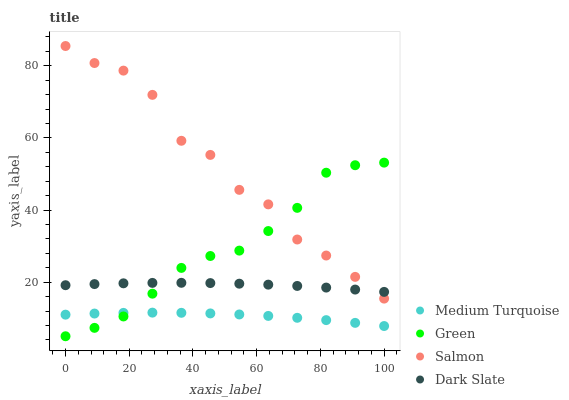Does Medium Turquoise have the minimum area under the curve?
Answer yes or no. Yes. Does Salmon have the maximum area under the curve?
Answer yes or no. Yes. Does Green have the minimum area under the curve?
Answer yes or no. No. Does Green have the maximum area under the curve?
Answer yes or no. No. Is Dark Slate the smoothest?
Answer yes or no. Yes. Is Salmon the roughest?
Answer yes or no. Yes. Is Green the smoothest?
Answer yes or no. No. Is Green the roughest?
Answer yes or no. No. Does Green have the lowest value?
Answer yes or no. Yes. Does Medium Turquoise have the lowest value?
Answer yes or no. No. Does Salmon have the highest value?
Answer yes or no. Yes. Does Green have the highest value?
Answer yes or no. No. Is Medium Turquoise less than Salmon?
Answer yes or no. Yes. Is Salmon greater than Medium Turquoise?
Answer yes or no. Yes. Does Salmon intersect Green?
Answer yes or no. Yes. Is Salmon less than Green?
Answer yes or no. No. Is Salmon greater than Green?
Answer yes or no. No. Does Medium Turquoise intersect Salmon?
Answer yes or no. No. 